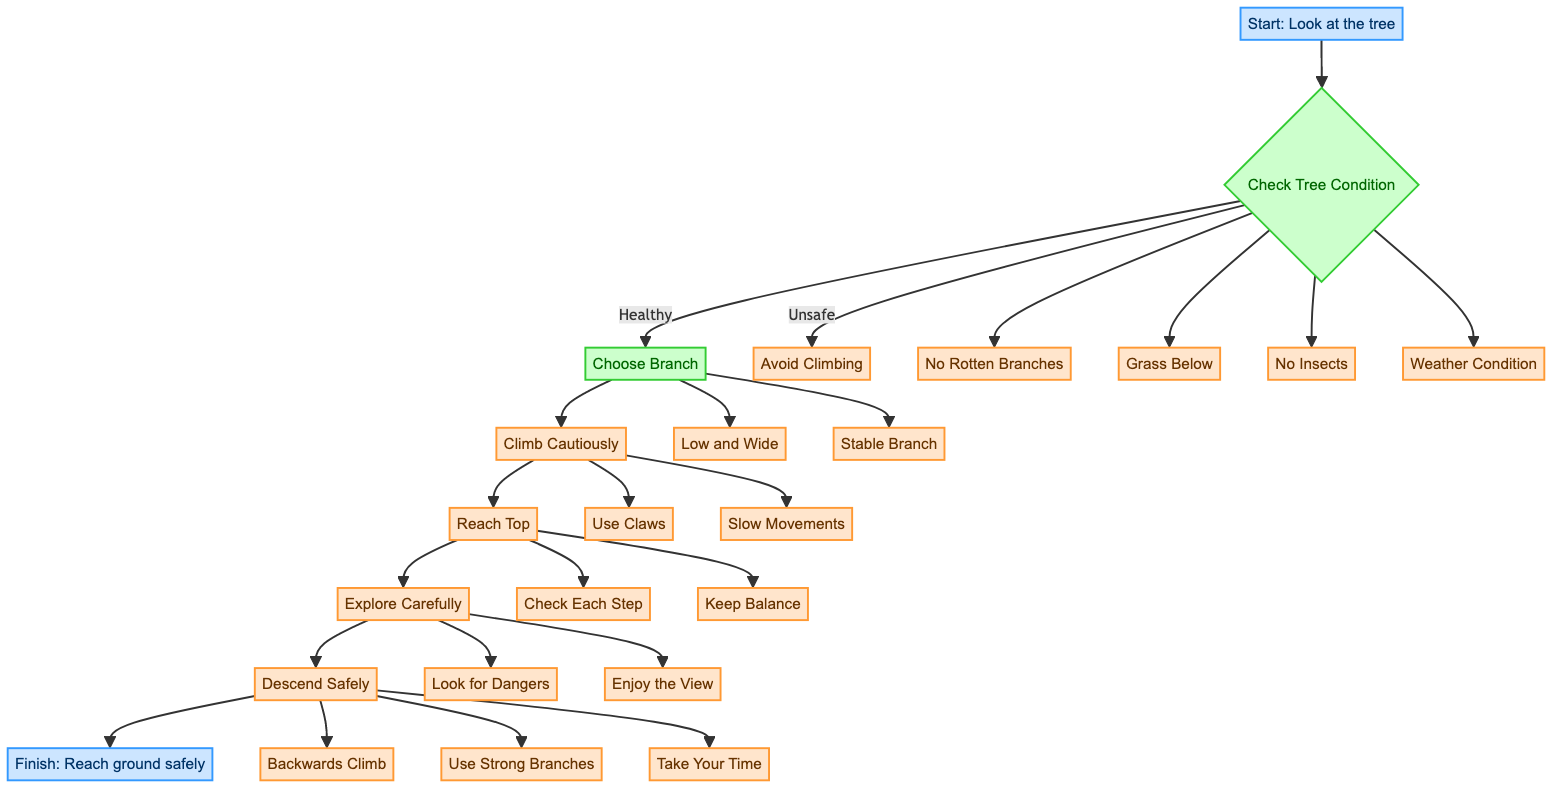What is the first step in the flowchart? The first step as indicated in the diagram is "Look at the tree," which is shown at the starting point of the flowchart.
Answer: Look at the tree How many conditions are checked in the "Check Tree Condition" step? In the diagram, there are four specific conditions listed below "Check Tree Condition," which are all necessary to confirm before climbing.
Answer: 4 What should you do if there are rotten branches? According to the flowchart, if there are rotten branches, the action specified is to "avoid climbing." This is a direct path leading from the decision point.
Answer: Avoid climbing What is the purpose of choosing a "Low and Wide" branch? The diagram states that the purpose of choosing a "Low and Wide" branch is that it is "easy to grip and balance," which explains why it's preferred for climbing.
Answer: Easy to grip and balance What actions are recommended during the "Explore Carefully" step? The diagram lists two actions under "Explore Carefully," which are "Look for Dangers" and "Enjoy the View," indicating things to consider while at the top of the tree.
Answer: Look for Dangers, Enjoy the View How should the descent be made according to the flowchart? The flowchart specifies in the "Descend Safely" step to "Backwards Climb," "Use Strong Branches," and "Take Your Time," outlining a safe approach for coming down the tree.
Answer: Backwards Climb, Use Strong Branches, Take Your Time What node directly follows "Reach Top" in the flowchart? After "Reach Top," the next node in the sequence is "Explore Carefully," which leads into the exploration phase after climbing up.
Answer: Explore Carefully If the weather condition is windy, what should you do? The diagram advises that if the weather condition is windy, it indicates you should refrain from climbing, which is a decision taken from the condition checks.
Answer: Don't climb What is needed to ensure a safe landing area when climbing? The diagram under "Check Tree Condition" specifies that there should be "Grass Below" to provide a soft landing area in case of a fall, which contributes to safety.
Answer: Grass Below 